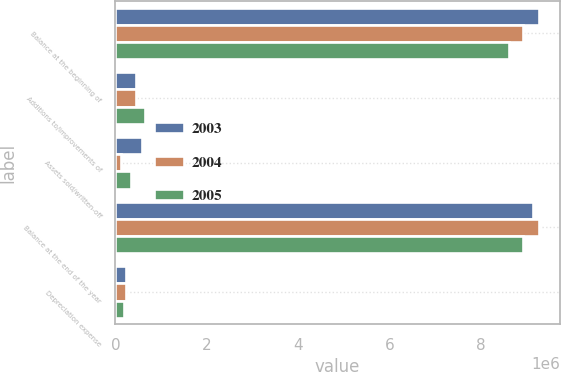Convert chart to OTSL. <chart><loc_0><loc_0><loc_500><loc_500><stacked_bar_chart><ecel><fcel>Balance at the beginning of<fcel>Additions to/improvements of<fcel>Assets sold/written-off<fcel>Balance at the end of the year<fcel>Depreciation expense<nl><fcel>2003<fcel>9.25664e+06<fcel>450641<fcel>580466<fcel>9.12681e+06<fcel>231790<nl><fcel>2004<fcel>8.91779e+06<fcel>454806<fcel>115955<fcel>9.25664e+06<fcel>222142<nl><fcel>2005<fcel>8.6207e+06<fcel>647977<fcel>350888<fcel>8.91779e+06<fcel>186886<nl></chart> 